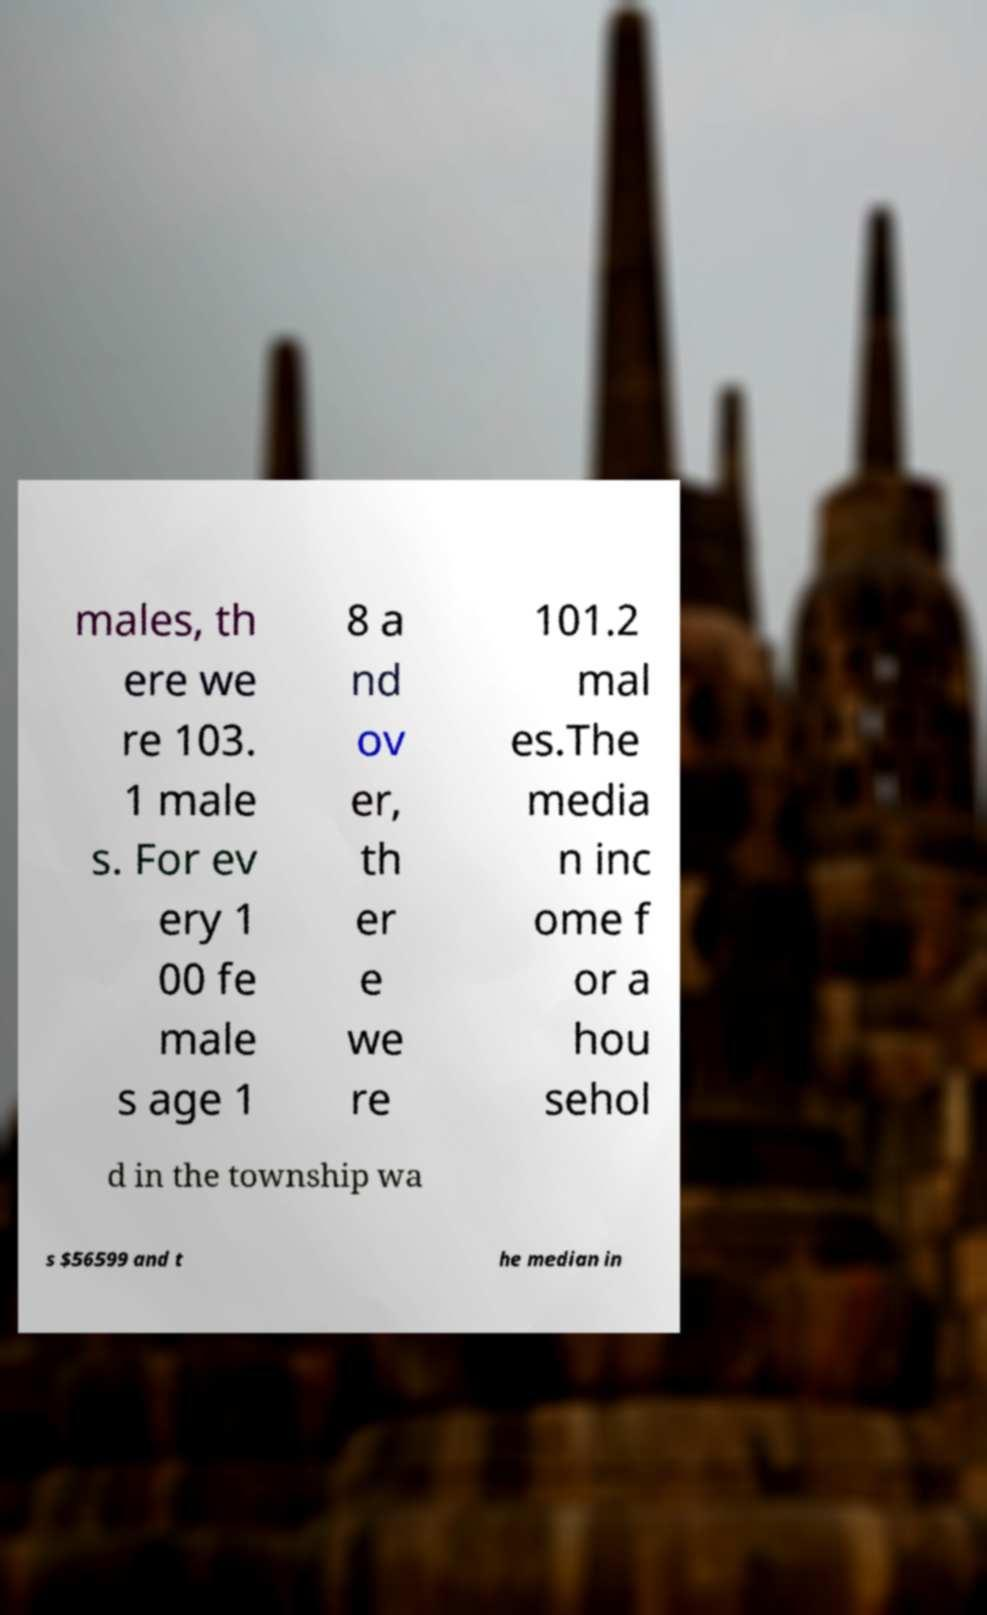Can you accurately transcribe the text from the provided image for me? males, th ere we re 103. 1 male s. For ev ery 1 00 fe male s age 1 8 a nd ov er, th er e we re 101.2 mal es.The media n inc ome f or a hou sehol d in the township wa s $56599 and t he median in 